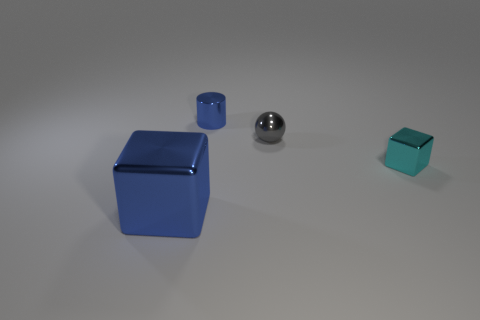There is a blue metallic object that is the same shape as the tiny cyan object; what is its size?
Give a very brief answer. Large. Are there more cubes behind the large blue metallic thing than tiny things behind the tiny gray metallic object?
Offer a terse response. No. What material is the tiny thing that is on the left side of the cyan metal block and to the right of the small cylinder?
Give a very brief answer. Metal. There is a large metal object that is the same shape as the tiny cyan metal object; what is its color?
Provide a succinct answer. Blue. The blue cube is what size?
Your response must be concise. Large. What is the color of the metal thing in front of the block that is right of the blue cylinder?
Provide a short and direct response. Blue. How many shiny objects are in front of the gray shiny ball and on the right side of the blue cylinder?
Ensure brevity in your answer.  1. Are there more tiny blue cubes than spheres?
Give a very brief answer. No. There is a shiny block that is right of the big blue cube; how many large things are on the left side of it?
Your answer should be very brief. 1. Do the tiny shiny cylinder and the thing that is to the left of the tiny shiny cylinder have the same color?
Your answer should be very brief. Yes. 